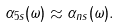<formula> <loc_0><loc_0><loc_500><loc_500>\alpha _ { 5 s } ( \omega ) \approx \alpha _ { n s } ( \omega ) .</formula> 